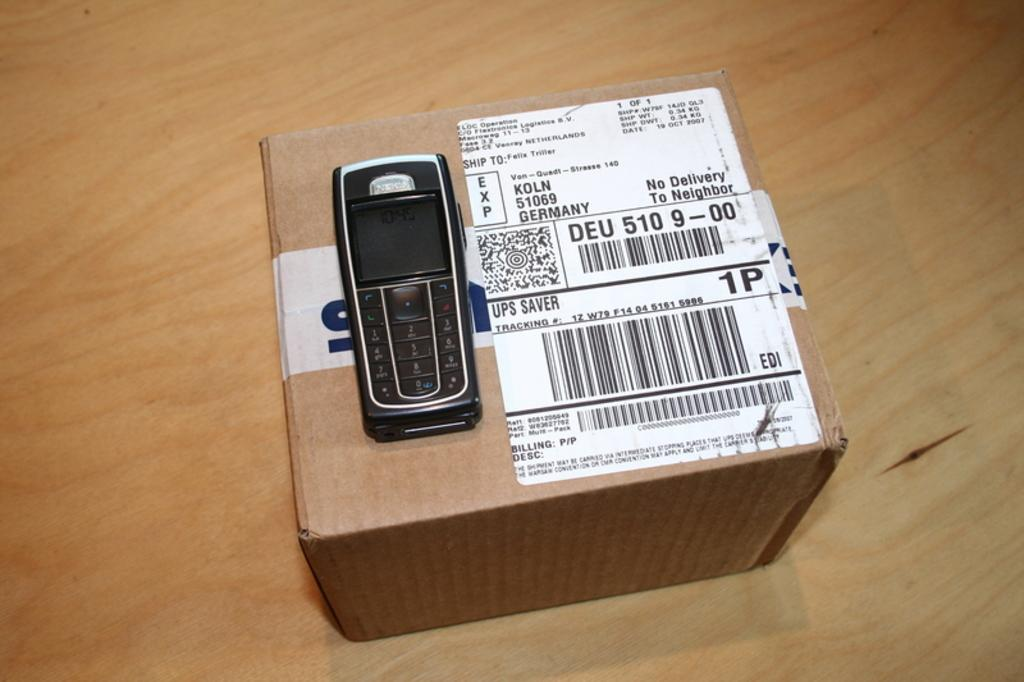<image>
Share a concise interpretation of the image provided. A cardboard box has a cell phone on top and the label says No Delivery To Neighbor. 